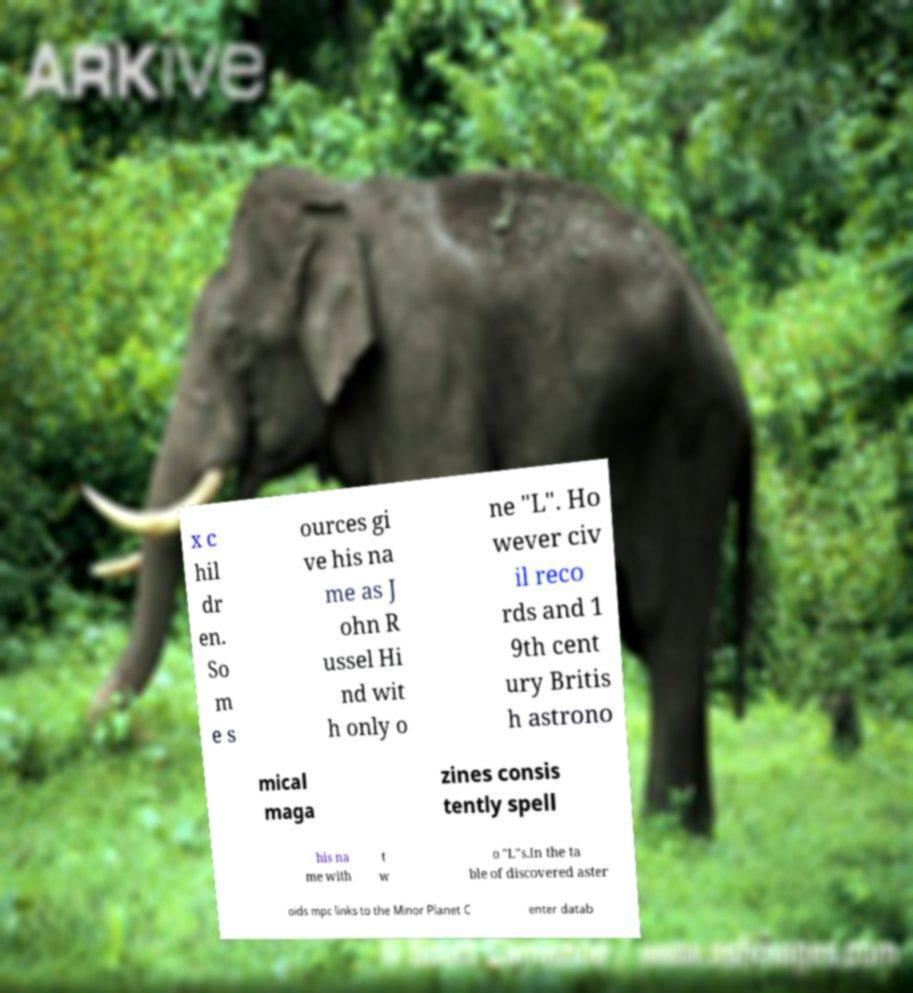Can you accurately transcribe the text from the provided image for me? x c hil dr en. So m e s ources gi ve his na me as J ohn R ussel Hi nd wit h only o ne "L". Ho wever civ il reco rds and 1 9th cent ury Britis h astrono mical maga zines consis tently spell his na me with t w o "L"s.In the ta ble of discovered aster oids mpc links to the Minor Planet C enter datab 